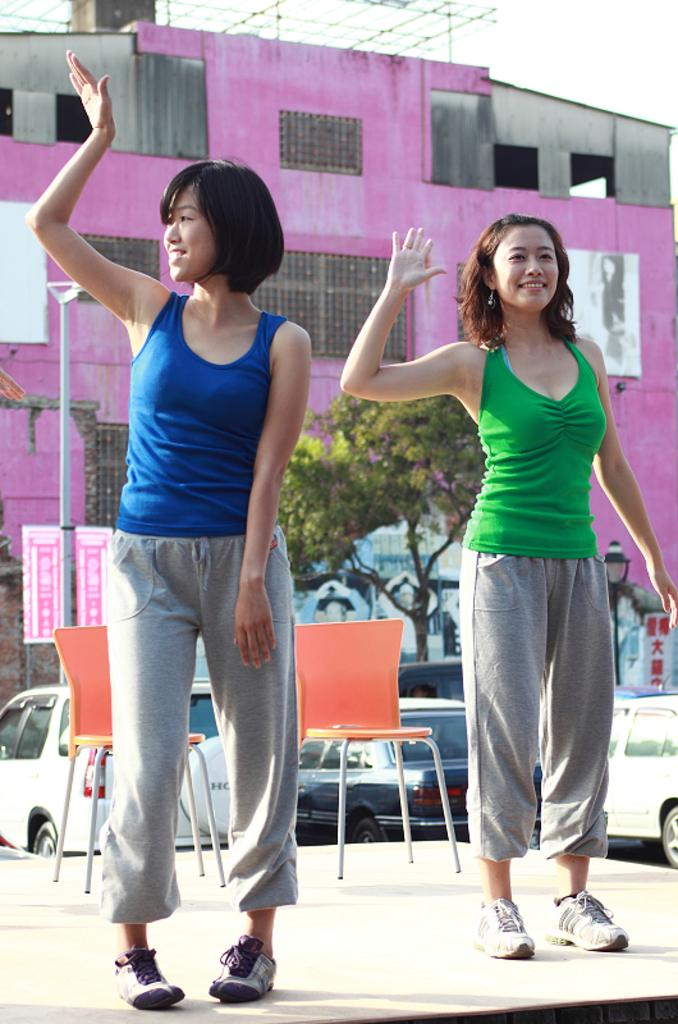How many people are in the image? There are two women in the image. What are the women doing in the image? The women appear to be dancing. What can be seen in the background of the image? There is a pink-colored house and a car visible in the background of the image. Where is the cactus located in the image? There is no cactus present in the image. What type of box is being used for breakfast in the image? There is no box or breakfast depicted in the image. 